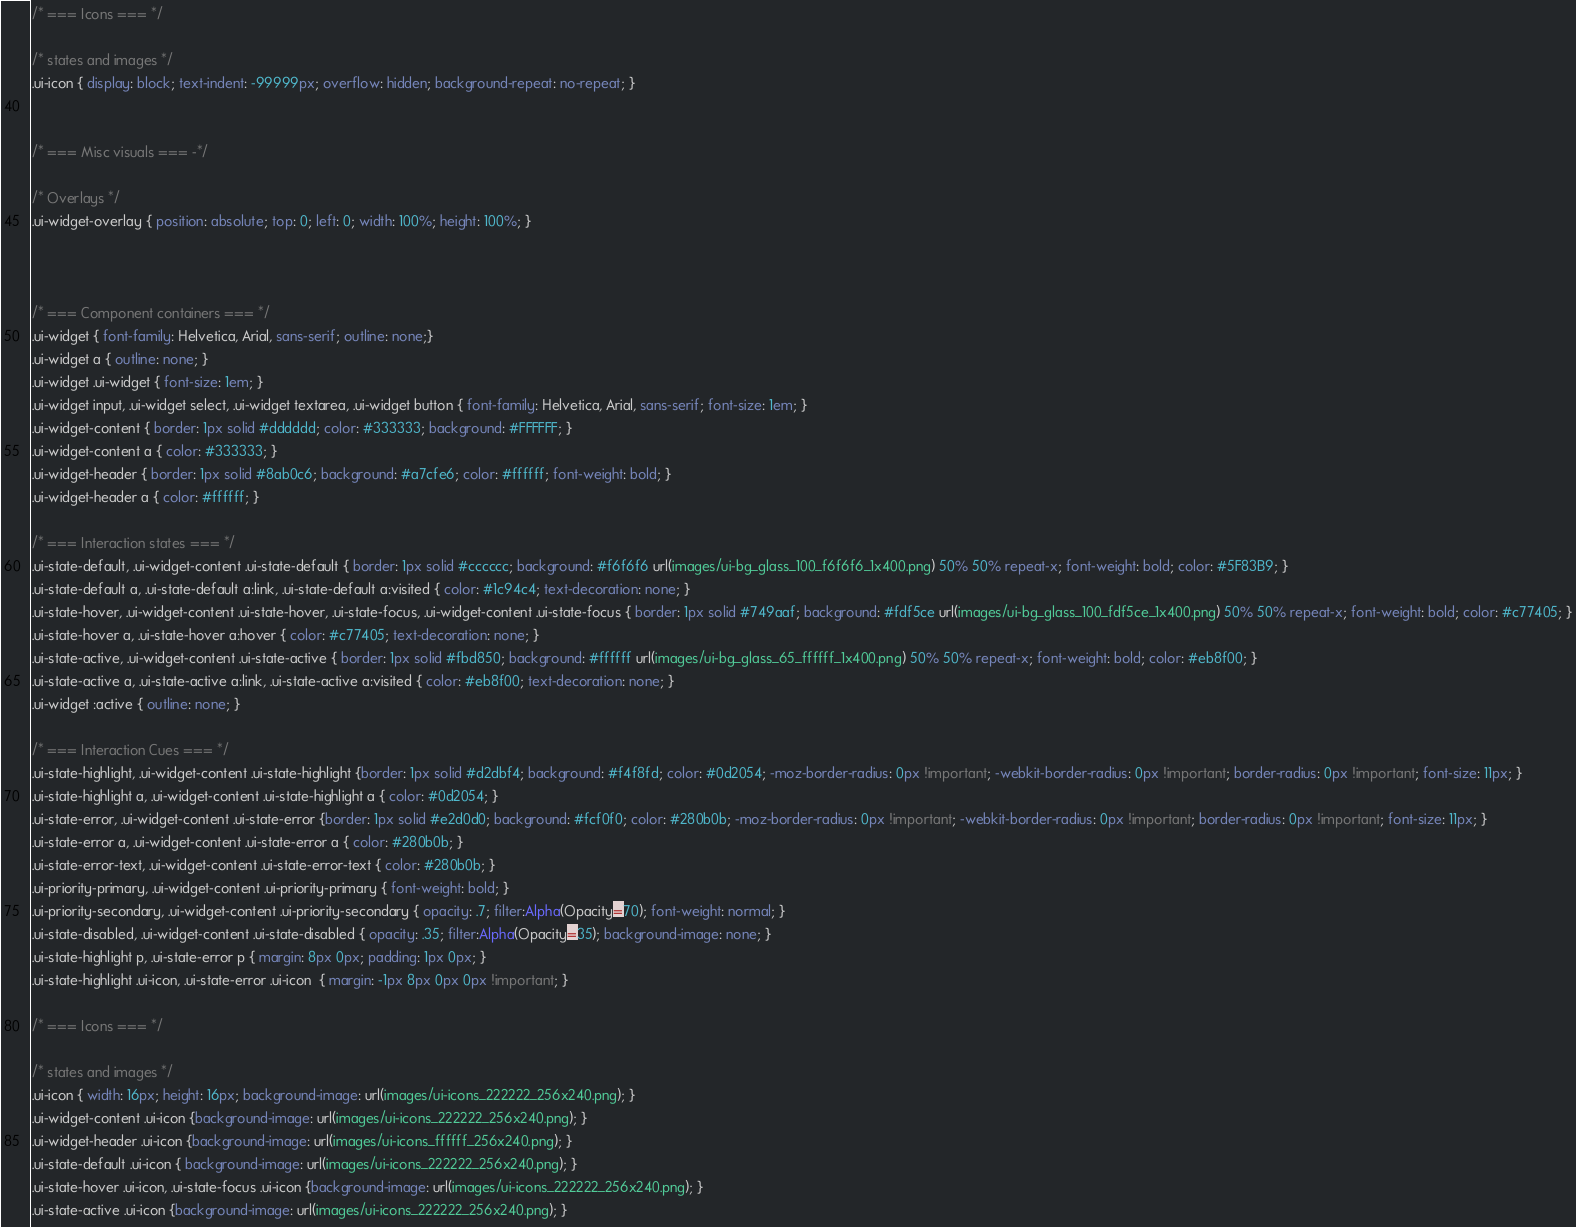<code> <loc_0><loc_0><loc_500><loc_500><_CSS_>
/* === Icons === */

/* states and images */
.ui-icon { display: block; text-indent: -99999px; overflow: hidden; background-repeat: no-repeat; }


/* === Misc visuals === -*/

/* Overlays */
.ui-widget-overlay { position: absolute; top: 0; left: 0; width: 100%; height: 100%; }



/* === Component containers === */
.ui-widget { font-family: Helvetica, Arial, sans-serif; outline: none;}
.ui-widget a { outline: none; }
.ui-widget .ui-widget { font-size: 1em; }
.ui-widget input, .ui-widget select, .ui-widget textarea, .ui-widget button { font-family: Helvetica, Arial, sans-serif; font-size: 1em; }
.ui-widget-content { border: 1px solid #dddddd; color: #333333; background: #FFFFFF; }
.ui-widget-content a { color: #333333; }
.ui-widget-header { border: 1px solid #8ab0c6; background: #a7cfe6; color: #ffffff; font-weight: bold; }
.ui-widget-header a { color: #ffffff; }

/* === Interaction states === */
.ui-state-default, .ui-widget-content .ui-state-default { border: 1px solid #cccccc; background: #f6f6f6 url(images/ui-bg_glass_100_f6f6f6_1x400.png) 50% 50% repeat-x; font-weight: bold; color: #5F83B9; }
.ui-state-default a, .ui-state-default a:link, .ui-state-default a:visited { color: #1c94c4; text-decoration: none; }
.ui-state-hover, .ui-widget-content .ui-state-hover, .ui-state-focus, .ui-widget-content .ui-state-focus { border: 1px solid #749aaf; background: #fdf5ce url(images/ui-bg_glass_100_fdf5ce_1x400.png) 50% 50% repeat-x; font-weight: bold; color: #c77405; }
.ui-state-hover a, .ui-state-hover a:hover { color: #c77405; text-decoration: none; }
.ui-state-active, .ui-widget-content .ui-state-active { border: 1px solid #fbd850; background: #ffffff url(images/ui-bg_glass_65_ffffff_1x400.png) 50% 50% repeat-x; font-weight: bold; color: #eb8f00; }
.ui-state-active a, .ui-state-active a:link, .ui-state-active a:visited { color: #eb8f00; text-decoration: none; }
.ui-widget :active { outline: none; }

/* === Interaction Cues === */
.ui-state-highlight, .ui-widget-content .ui-state-highlight {border: 1px solid #d2dbf4; background: #f4f8fd; color: #0d2054; -moz-border-radius: 0px !important; -webkit-border-radius: 0px !important; border-radius: 0px !important; font-size: 11px; }
.ui-state-highlight a, .ui-widget-content .ui-state-highlight a { color: #0d2054; }
.ui-state-error, .ui-widget-content .ui-state-error {border: 1px solid #e2d0d0; background: #fcf0f0; color: #280b0b; -moz-border-radius: 0px !important; -webkit-border-radius: 0px !important; border-radius: 0px !important; font-size: 11px; }
.ui-state-error a, .ui-widget-content .ui-state-error a { color: #280b0b; }
.ui-state-error-text, .ui-widget-content .ui-state-error-text { color: #280b0b; }
.ui-priority-primary, .ui-widget-content .ui-priority-primary { font-weight: bold; }
.ui-priority-secondary, .ui-widget-content .ui-priority-secondary { opacity: .7; filter:Alpha(Opacity=70); font-weight: normal; }
.ui-state-disabled, .ui-widget-content .ui-state-disabled { opacity: .35; filter:Alpha(Opacity=35); background-image: none; }
.ui-state-highlight p, .ui-state-error p { margin: 8px 0px; padding: 1px 0px; }
.ui-state-highlight .ui-icon, .ui-state-error .ui-icon  { margin: -1px 8px 0px 0px !important; }

/* === Icons === */

/* states and images */
.ui-icon { width: 16px; height: 16px; background-image: url(images/ui-icons_222222_256x240.png); }
.ui-widget-content .ui-icon {background-image: url(images/ui-icons_222222_256x240.png); }
.ui-widget-header .ui-icon {background-image: url(images/ui-icons_ffffff_256x240.png); }
.ui-state-default .ui-icon { background-image: url(images/ui-icons_222222_256x240.png); }
.ui-state-hover .ui-icon, .ui-state-focus .ui-icon {background-image: url(images/ui-icons_222222_256x240.png); }
.ui-state-active .ui-icon {background-image: url(images/ui-icons_222222_256x240.png); }</code> 